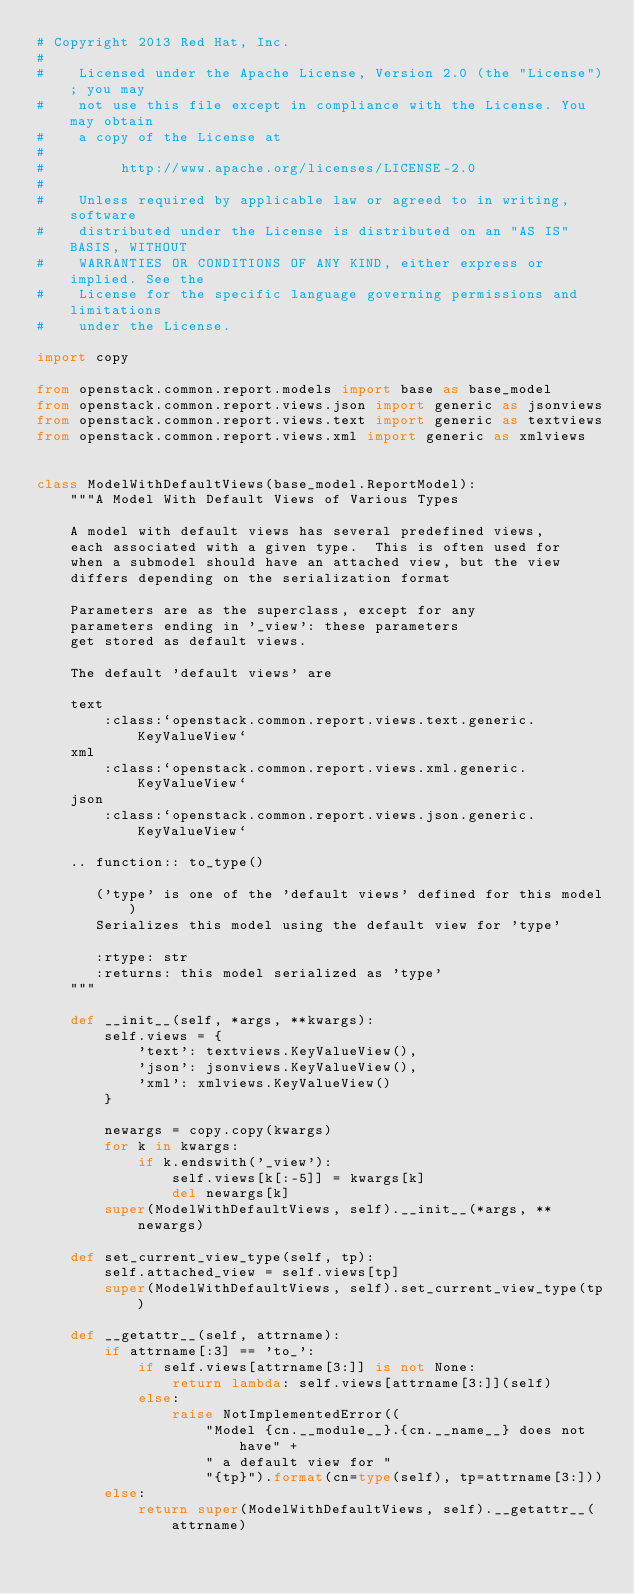<code> <loc_0><loc_0><loc_500><loc_500><_Python_># Copyright 2013 Red Hat, Inc.
#
#    Licensed under the Apache License, Version 2.0 (the "License"); you may
#    not use this file except in compliance with the License. You may obtain
#    a copy of the License at
#
#         http://www.apache.org/licenses/LICENSE-2.0
#
#    Unless required by applicable law or agreed to in writing, software
#    distributed under the License is distributed on an "AS IS" BASIS, WITHOUT
#    WARRANTIES OR CONDITIONS OF ANY KIND, either express or implied. See the
#    License for the specific language governing permissions and limitations
#    under the License.

import copy

from openstack.common.report.models import base as base_model
from openstack.common.report.views.json import generic as jsonviews
from openstack.common.report.views.text import generic as textviews
from openstack.common.report.views.xml import generic as xmlviews


class ModelWithDefaultViews(base_model.ReportModel):
    """A Model With Default Views of Various Types

    A model with default views has several predefined views,
    each associated with a given type.  This is often used for
    when a submodel should have an attached view, but the view
    differs depending on the serialization format

    Parameters are as the superclass, except for any
    parameters ending in '_view': these parameters
    get stored as default views.

    The default 'default views' are

    text
        :class:`openstack.common.report.views.text.generic.KeyValueView`
    xml
        :class:`openstack.common.report.views.xml.generic.KeyValueView`
    json
        :class:`openstack.common.report.views.json.generic.KeyValueView`

    .. function:: to_type()

       ('type' is one of the 'default views' defined for this model)
       Serializes this model using the default view for 'type'

       :rtype: str
       :returns: this model serialized as 'type'
    """

    def __init__(self, *args, **kwargs):
        self.views = {
            'text': textviews.KeyValueView(),
            'json': jsonviews.KeyValueView(),
            'xml': xmlviews.KeyValueView()
        }

        newargs = copy.copy(kwargs)
        for k in kwargs:
            if k.endswith('_view'):
                self.views[k[:-5]] = kwargs[k]
                del newargs[k]
        super(ModelWithDefaultViews, self).__init__(*args, **newargs)

    def set_current_view_type(self, tp):
        self.attached_view = self.views[tp]
        super(ModelWithDefaultViews, self).set_current_view_type(tp)

    def __getattr__(self, attrname):
        if attrname[:3] == 'to_':
            if self.views[attrname[3:]] is not None:
                return lambda: self.views[attrname[3:]](self)
            else:
                raise NotImplementedError((
                    "Model {cn.__module__}.{cn.__name__} does not have" +
                    " a default view for "
                    "{tp}").format(cn=type(self), tp=attrname[3:]))
        else:
            return super(ModelWithDefaultViews, self).__getattr__(attrname)
</code> 